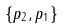Convert formula to latex. <formula><loc_0><loc_0><loc_500><loc_500>\{ p _ { 2 } , p _ { 1 } \}</formula> 